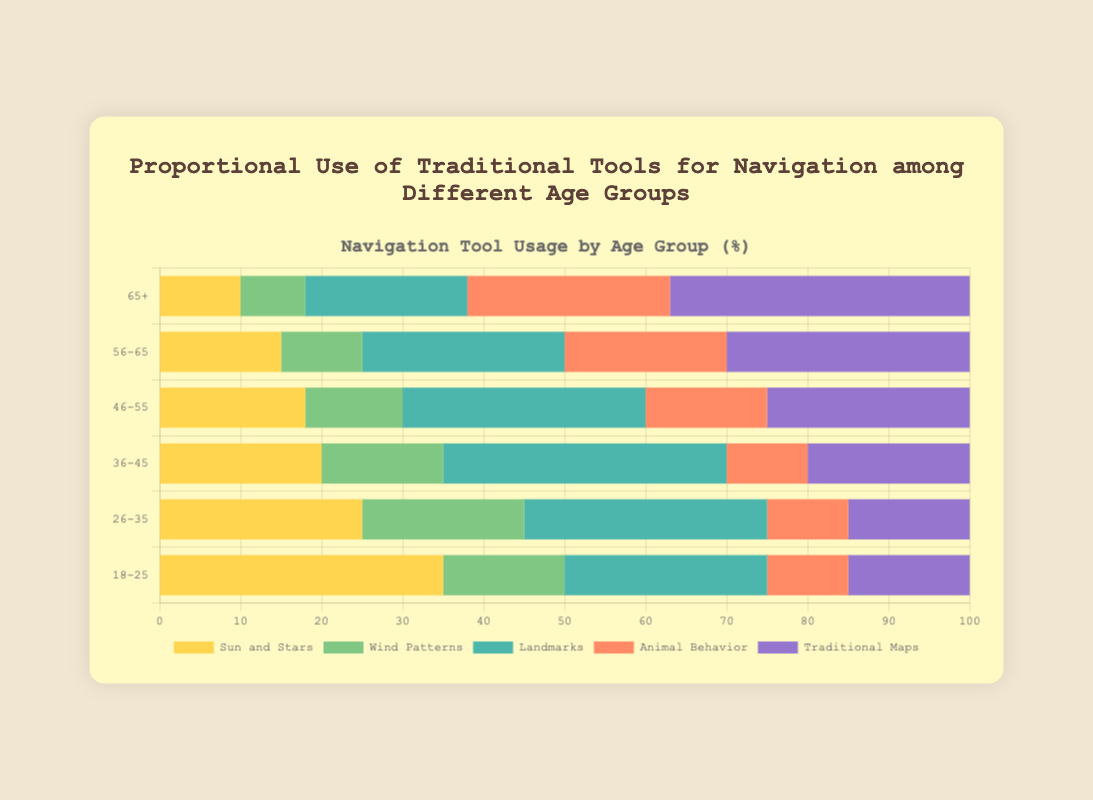What age group uses "Sun and Stars" the most and the least? The age group using "Sun and Stars" the most is 18-25 with 35 units, while the age group using it the least is 65+ with 10 units.
Answer: 18-25 and 65+ Which traditional tool has the highest usage in the 65+ age group? The traditional tool with the highest usage in the 65+ age group is "Traditional Maps" at 37 units.
Answer: Traditional Maps What is the average usage of "Wind Patterns" across all age groups? Summing the usage of "Wind Patterns" (15+20+15+12+10+8=80) and dividing by the number of age groups (6) gives the average usage: 80/6 = 13.33.
Answer: 13.33 Which age group has the highest combined usage of "Animal Behavior" and "Landmarks"? For each age group, add usage of "Animal Behavior" and "Landmarks": 18-25: 10+25=35, 26-35: 10+30=40, 36-45: 10+35=45, 46-55: 15+30=45, 56-65: 20+25=45, 65+: 25+20=45. The highest combined usage is 45 for age groups 36-45, 46-55, 56-65, and 65+.
Answer: 36-45, 46-55, 56-65, 65+ Does the usage of "Traditional Maps" increase or decrease with age? Observing the data: 18-25: 15, 26-35: 15, 36-45: 20, 46-55: 25, 56-65: 30, 65+: 37, the usage of "Traditional Maps" increases with age.
Answer: Increases For the 46-55 age group, what is the total usage of all traditional tools? Sum the values for the 46-55 age group: 18 (Sun and Stars) + 12 (Wind Patterns) + 30 (Landmarks) + 15 (Animal Behavior) + 25 (Traditional Maps) = 100.
Answer: 100 Which tool is least used by the 18-25 age group? The least used tool by the 18-25 age group is "Animal Behavior" with 10 units.
Answer: Animal Behavior In the 56-65 age group, is the usage of "Traditional Maps" greater than "Animal Behavior" and "Landmarks" combined? For the 56-65 age group, "Traditional Maps" is 30 and the combined usage of "Animal Behavior" and "Landmarks" is 20+25=45. 30 is not greater than 45.
Answer: No How does the usage of "Landmarks" change from the 18-25 age group to the 26-35 age group? The usage of "Landmarks" increases from 25 in the 18-25 age group to 30 in the 26-35 age group.
Answer: Increases What is the total usage of "Sun and Stars" across all age groups? Summing the usage of "Sun and Stars": 35+25+20+18+15+10 = 123 units.
Answer: 123 